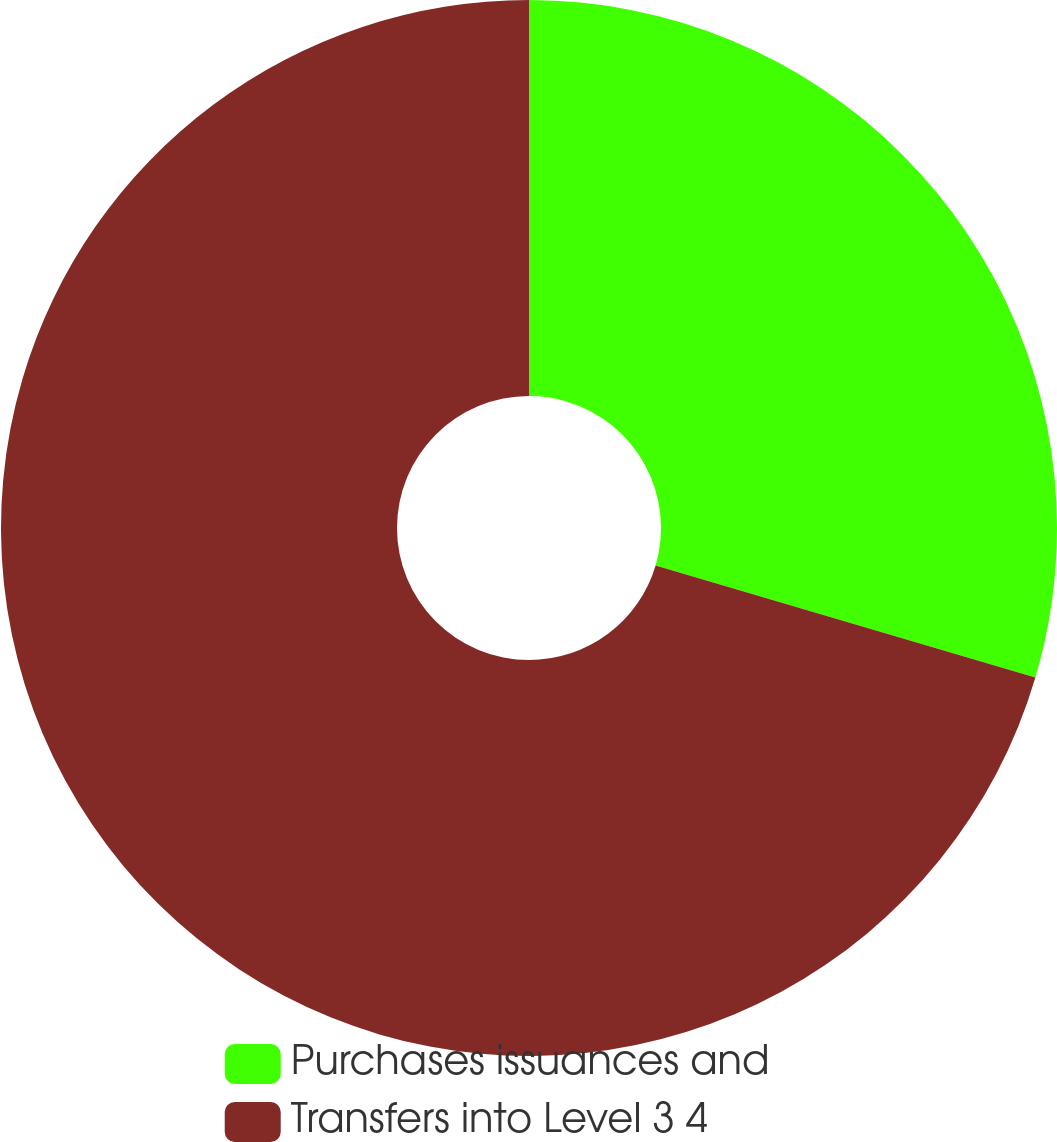Convert chart to OTSL. <chart><loc_0><loc_0><loc_500><loc_500><pie_chart><fcel>Purchases issuances and<fcel>Transfers into Level 3 4<nl><fcel>29.57%<fcel>70.43%<nl></chart> 